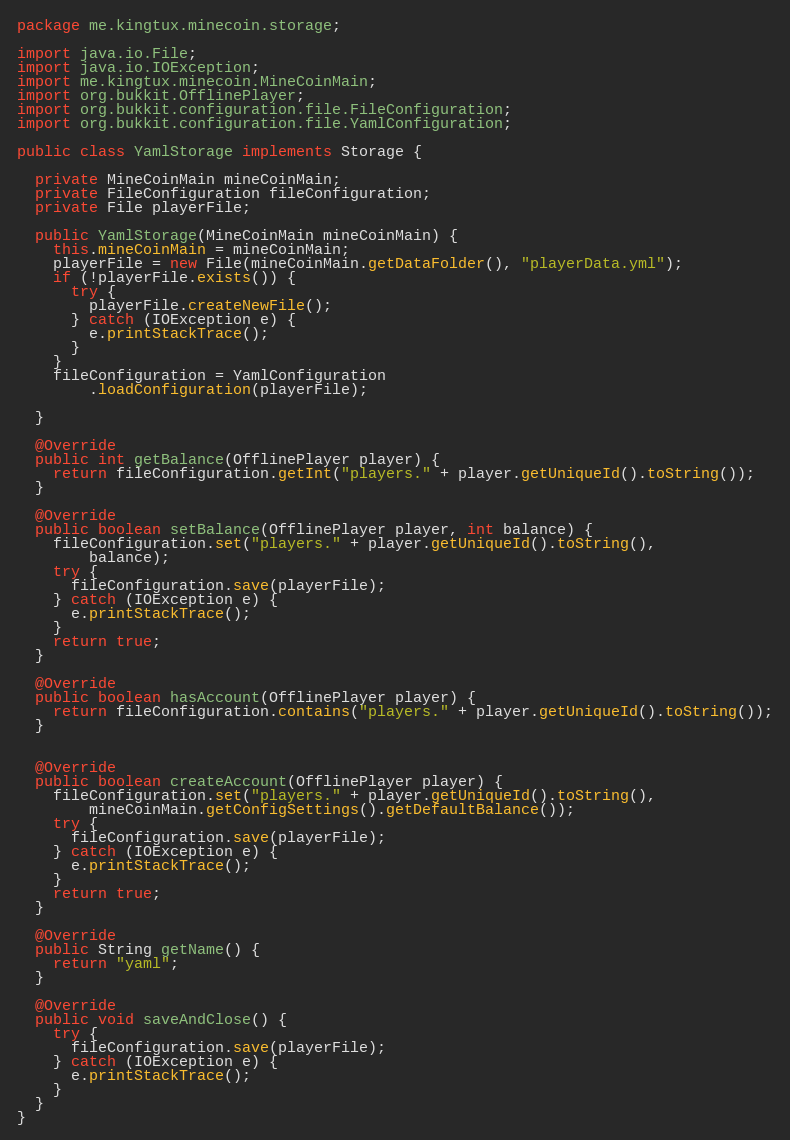Convert code to text. <code><loc_0><loc_0><loc_500><loc_500><_Java_>package me.kingtux.minecoin.storage;

import java.io.File;
import java.io.IOException;
import me.kingtux.minecoin.MineCoinMain;
import org.bukkit.OfflinePlayer;
import org.bukkit.configuration.file.FileConfiguration;
import org.bukkit.configuration.file.YamlConfiguration;

public class YamlStorage implements Storage {

  private MineCoinMain mineCoinMain;
  private FileConfiguration fileConfiguration;
  private File playerFile;

  public YamlStorage(MineCoinMain mineCoinMain) {
    this.mineCoinMain = mineCoinMain;
    playerFile = new File(mineCoinMain.getDataFolder(), "playerData.yml");
    if (!playerFile.exists()) {
      try {
        playerFile.createNewFile();
      } catch (IOException e) {
        e.printStackTrace();
      }
    }
    fileConfiguration = YamlConfiguration
        .loadConfiguration(playerFile);

  }

  @Override
  public int getBalance(OfflinePlayer player) {
    return fileConfiguration.getInt("players." + player.getUniqueId().toString());
  }

  @Override
  public boolean setBalance(OfflinePlayer player, int balance) {
    fileConfiguration.set("players." + player.getUniqueId().toString(),
        balance);
    try {
      fileConfiguration.save(playerFile);
    } catch (IOException e) {
      e.printStackTrace();
    }
    return true;
  }

  @Override
  public boolean hasAccount(OfflinePlayer player) {
    return fileConfiguration.contains("players." + player.getUniqueId().toString());
  }


  @Override
  public boolean createAccount(OfflinePlayer player) {
    fileConfiguration.set("players." + player.getUniqueId().toString(),
        mineCoinMain.getConfigSettings().getDefaultBalance());
    try {
      fileConfiguration.save(playerFile);
    } catch (IOException e) {
      e.printStackTrace();
    }
    return true;
  }

  @Override
  public String getName() {
    return "yaml";
  }

  @Override
  public void saveAndClose() {
    try {
      fileConfiguration.save(playerFile);
    } catch (IOException e) {
      e.printStackTrace();
    }
  }
}
</code> 